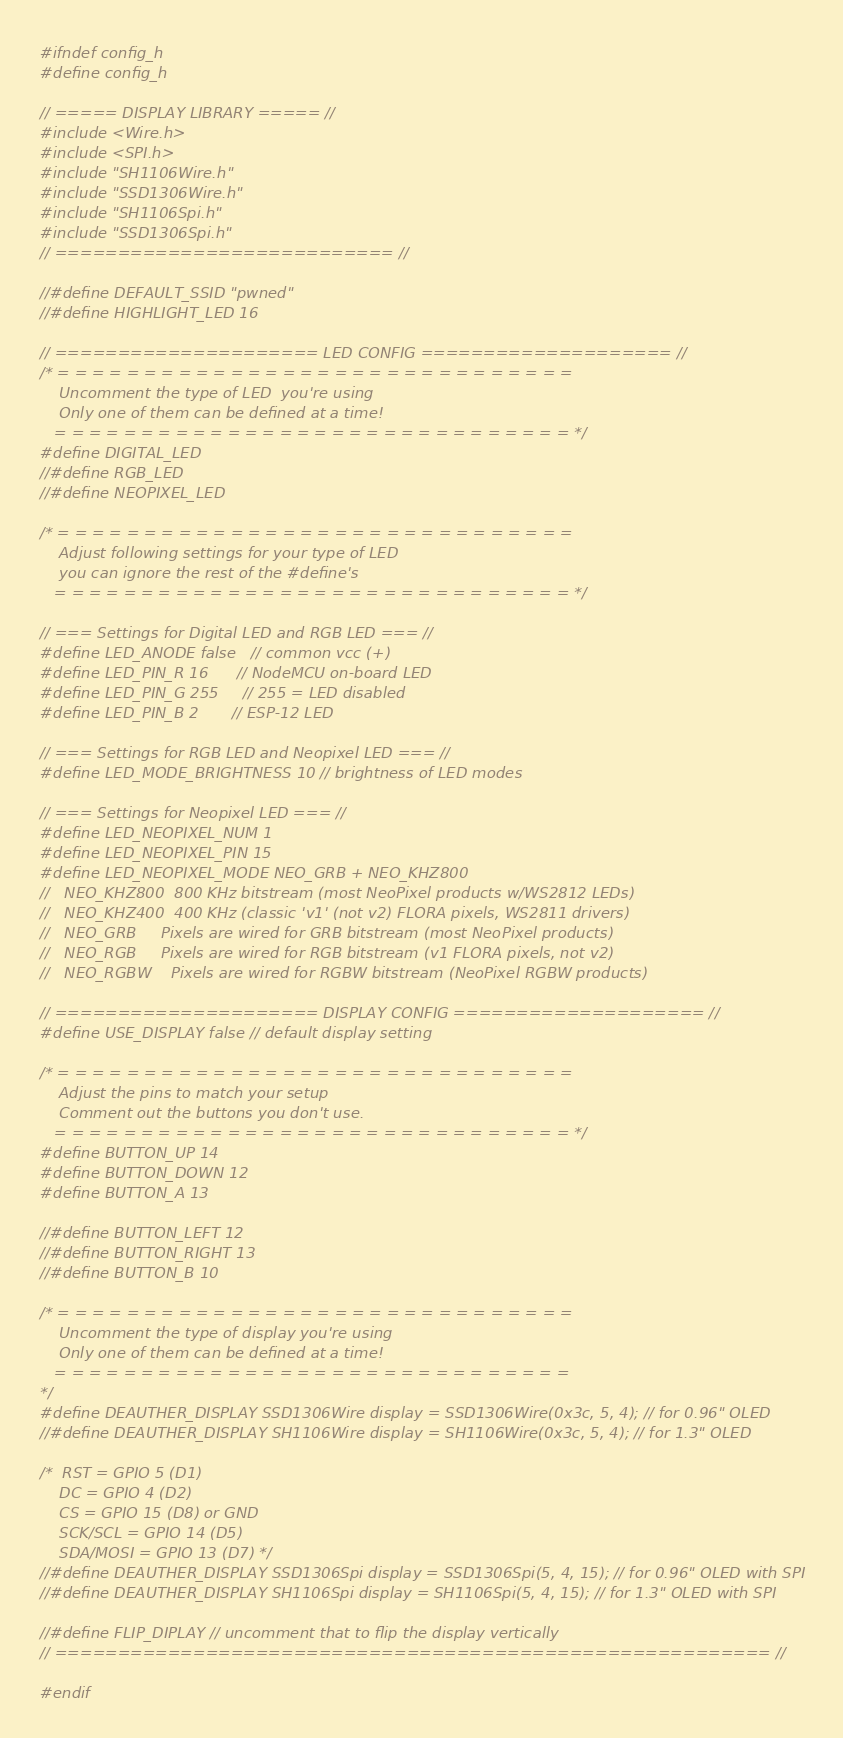Convert code to text. <code><loc_0><loc_0><loc_500><loc_500><_C_>#ifndef config_h
#define config_h

// ===== DISPLAY LIBRARY ===== //
#include <Wire.h>
#include <SPI.h>
#include "SH1106Wire.h"
#include "SSD1306Wire.h"
#include "SH1106Spi.h"
#include "SSD1306Spi.h"
// =========================== //

//#define DEFAULT_SSID "pwned"
//#define HIGHLIGHT_LED 16

// ===================== LED CONFIG ==================== //
/* = = = = = = = = = = = = = = = = = = = = = = = = = = = = = =
    Uncomment the type of LED  you're using
    Only one of them can be defined at a time!
   = = = = = = = = = = = = = = = = = = = = = = = = = = = = = = */
#define DIGITAL_LED
//#define RGB_LED
//#define NEOPIXEL_LED

/* = = = = = = = = = = = = = = = = = = = = = = = = = = = = = =
    Adjust following settings for your type of LED
    you can ignore the rest of the #define's
   = = = = = = = = = = = = = = = = = = = = = = = = = = = = = = */
   
// === Settings for Digital LED and RGB LED === //
#define LED_ANODE false   // common vcc (+)
#define LED_PIN_R 16      // NodeMCU on-board LED
#define LED_PIN_G 255     // 255 = LED disabled
#define LED_PIN_B 2       // ESP-12 LED

// === Settings for RGB LED and Neopixel LED === //
#define LED_MODE_BRIGHTNESS 10 // brightness of LED modes 

// === Settings for Neopixel LED === //
#define LED_NEOPIXEL_NUM 1
#define LED_NEOPIXEL_PIN 15
#define LED_NEOPIXEL_MODE NEO_GRB + NEO_KHZ800
//   NEO_KHZ800  800 KHz bitstream (most NeoPixel products w/WS2812 LEDs)
//   NEO_KHZ400  400 KHz (classic 'v1' (not v2) FLORA pixels, WS2811 drivers)
//   NEO_GRB     Pixels are wired for GRB bitstream (most NeoPixel products)
//   NEO_RGB     Pixels are wired for RGB bitstream (v1 FLORA pixels, not v2)
//   NEO_RGBW    Pixels are wired for RGBW bitstream (NeoPixel RGBW products)

// ===================== DISPLAY CONFIG ==================== //
#define USE_DISPLAY false // default display setting

/* = = = = = = = = = = = = = = = = = = = = = = = = = = = = = =
    Adjust the pins to match your setup
    Comment out the buttons you don't use.
   = = = = = = = = = = = = = = = = = = = = = = = = = = = = = = */
#define BUTTON_UP 14
#define BUTTON_DOWN 12
#define BUTTON_A 13

//#define BUTTON_LEFT 12
//#define BUTTON_RIGHT 13
//#define BUTTON_B 10

/* = = = = = = = = = = = = = = = = = = = = = = = = = = = = = =
    Uncomment the type of display you're using
    Only one of them can be defined at a time!
   = = = = = = = = = = = = = = = = = = = = = = = = = = = = = =
*/
#define DEAUTHER_DISPLAY SSD1306Wire display = SSD1306Wire(0x3c, 5, 4); // for 0.96" OLED
//#define DEAUTHER_DISPLAY SH1106Wire display = SH1106Wire(0x3c, 5, 4); // for 1.3" OLED

/*  RST = GPIO 5 (D1)
    DC = GPIO 4 (D2)
    CS = GPIO 15 (D8) or GND
    SCK/SCL = GPIO 14 (D5)
    SDA/MOSI = GPIO 13 (D7) */
//#define DEAUTHER_DISPLAY SSD1306Spi display = SSD1306Spi(5, 4, 15); // for 0.96" OLED with SPI
//#define DEAUTHER_DISPLAY SH1106Spi display = SH1106Spi(5, 4, 15); // for 1.3" OLED with SPI

//#define FLIP_DIPLAY // uncomment that to flip the display vertically
// ========================================================= //

#endif
</code> 